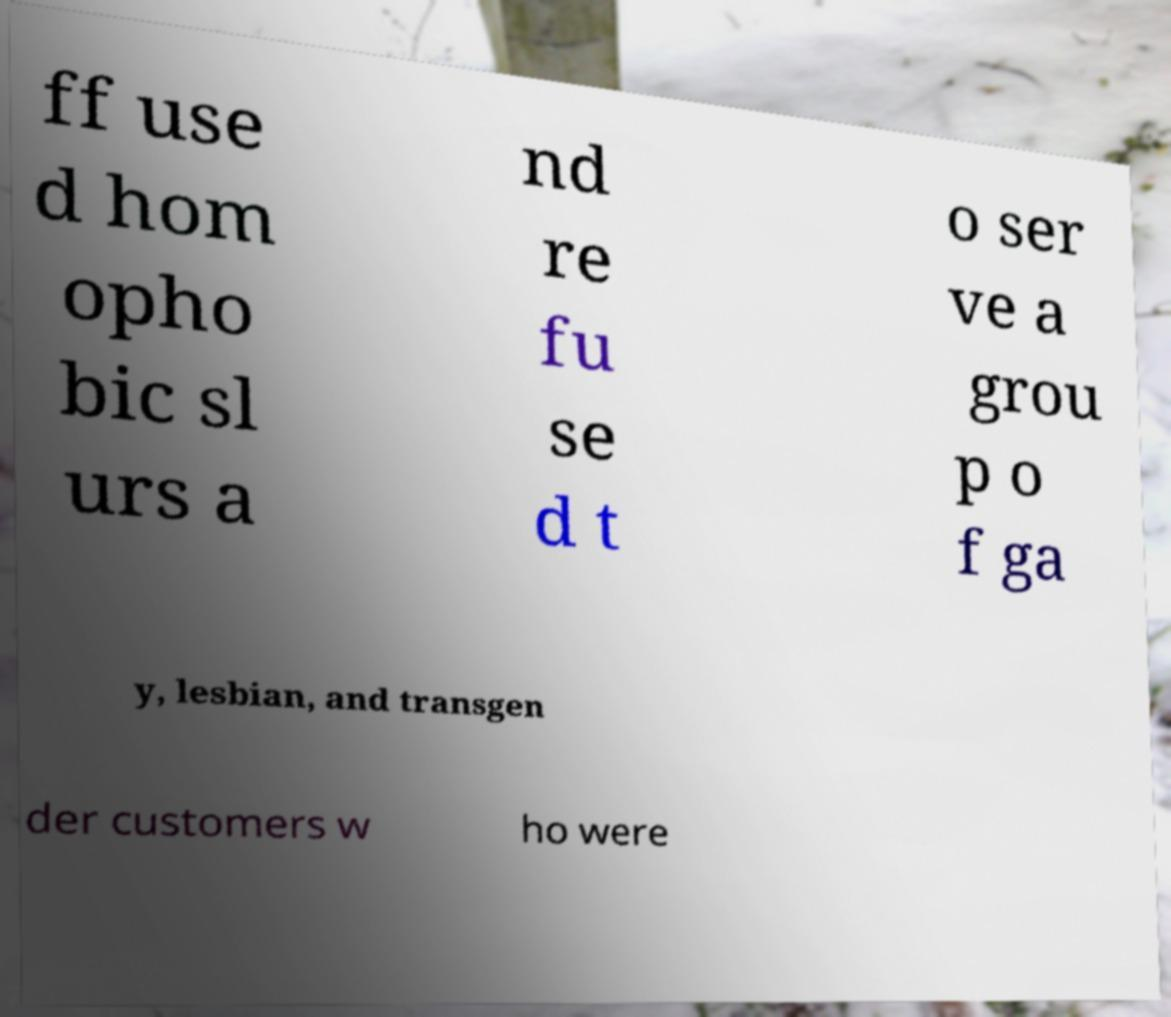There's text embedded in this image that I need extracted. Can you transcribe it verbatim? ff use d hom opho bic sl urs a nd re fu se d t o ser ve a grou p o f ga y, lesbian, and transgen der customers w ho were 